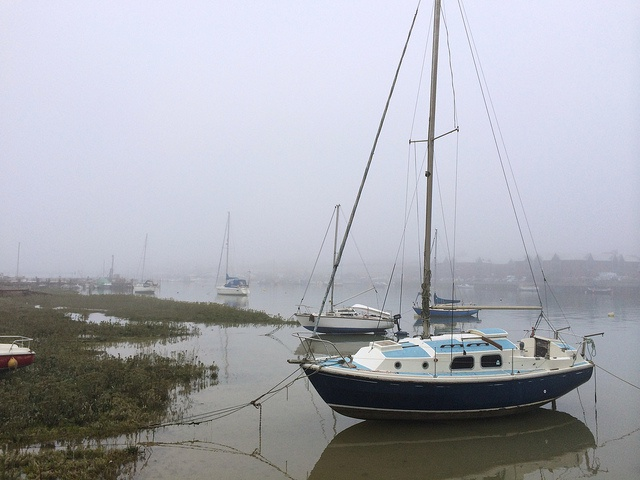Describe the objects in this image and their specific colors. I can see boat in lavender, darkgray, black, and gray tones, boat in lavender, black, maroon, and gray tones, boat in lavender, darkgray, lightgray, and gray tones, boat in lavender, gray, darkblue, and darkgray tones, and boat in lavender, darkgray, and gray tones in this image. 